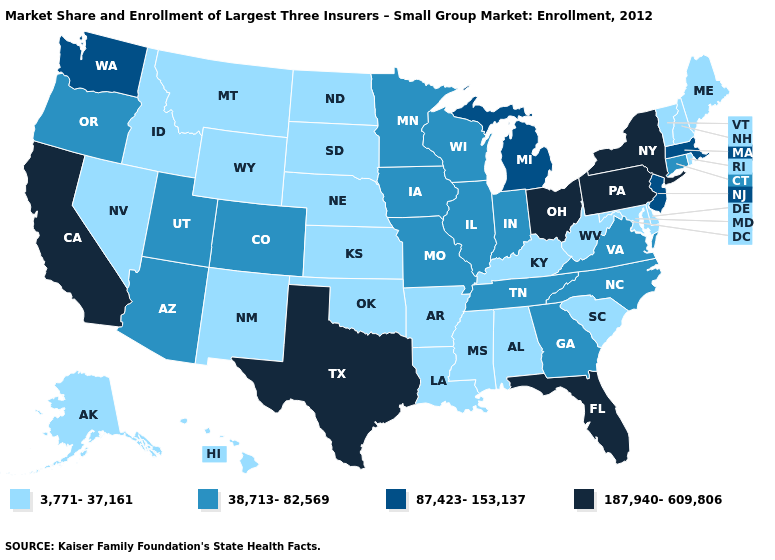What is the highest value in the Northeast ?
Give a very brief answer. 187,940-609,806. Name the states that have a value in the range 87,423-153,137?
Short answer required. Massachusetts, Michigan, New Jersey, Washington. Name the states that have a value in the range 3,771-37,161?
Keep it brief. Alabama, Alaska, Arkansas, Delaware, Hawaii, Idaho, Kansas, Kentucky, Louisiana, Maine, Maryland, Mississippi, Montana, Nebraska, Nevada, New Hampshire, New Mexico, North Dakota, Oklahoma, Rhode Island, South Carolina, South Dakota, Vermont, West Virginia, Wyoming. Does Texas have the highest value in the USA?
Be succinct. Yes. Name the states that have a value in the range 3,771-37,161?
Write a very short answer. Alabama, Alaska, Arkansas, Delaware, Hawaii, Idaho, Kansas, Kentucky, Louisiana, Maine, Maryland, Mississippi, Montana, Nebraska, Nevada, New Hampshire, New Mexico, North Dakota, Oklahoma, Rhode Island, South Carolina, South Dakota, Vermont, West Virginia, Wyoming. Which states have the lowest value in the Northeast?
Quick response, please. Maine, New Hampshire, Rhode Island, Vermont. Name the states that have a value in the range 3,771-37,161?
Quick response, please. Alabama, Alaska, Arkansas, Delaware, Hawaii, Idaho, Kansas, Kentucky, Louisiana, Maine, Maryland, Mississippi, Montana, Nebraska, Nevada, New Hampshire, New Mexico, North Dakota, Oklahoma, Rhode Island, South Carolina, South Dakota, Vermont, West Virginia, Wyoming. Does Louisiana have the lowest value in the USA?
Quick response, please. Yes. What is the value of West Virginia?
Give a very brief answer. 3,771-37,161. What is the value of Illinois?
Be succinct. 38,713-82,569. Name the states that have a value in the range 87,423-153,137?
Write a very short answer. Massachusetts, Michigan, New Jersey, Washington. Which states have the highest value in the USA?
Concise answer only. California, Florida, New York, Ohio, Pennsylvania, Texas. What is the value of Arizona?
Write a very short answer. 38,713-82,569. Does Oklahoma have a higher value than North Carolina?
Short answer required. No. Name the states that have a value in the range 187,940-609,806?
Concise answer only. California, Florida, New York, Ohio, Pennsylvania, Texas. 